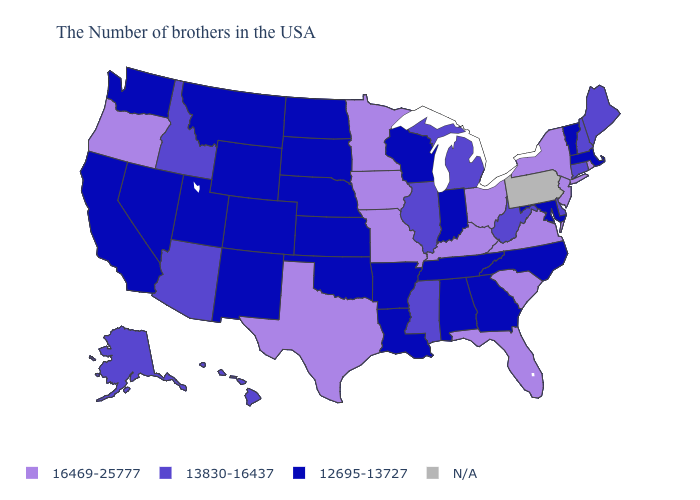What is the value of Kentucky?
Answer briefly. 16469-25777. What is the value of Oklahoma?
Concise answer only. 12695-13727. Does Oregon have the highest value in the West?
Concise answer only. Yes. Which states hav the highest value in the Northeast?
Short answer required. Rhode Island, New York, New Jersey. What is the highest value in the USA?
Answer briefly. 16469-25777. Name the states that have a value in the range 12695-13727?
Quick response, please. Massachusetts, Vermont, Maryland, North Carolina, Georgia, Indiana, Alabama, Tennessee, Wisconsin, Louisiana, Arkansas, Kansas, Nebraska, Oklahoma, South Dakota, North Dakota, Wyoming, Colorado, New Mexico, Utah, Montana, Nevada, California, Washington. Name the states that have a value in the range N/A?
Quick response, please. Pennsylvania. Name the states that have a value in the range 13830-16437?
Quick response, please. Maine, New Hampshire, Connecticut, Delaware, West Virginia, Michigan, Illinois, Mississippi, Arizona, Idaho, Alaska, Hawaii. Among the states that border Oregon , does Washington have the highest value?
Keep it brief. No. What is the highest value in states that border Massachusetts?
Short answer required. 16469-25777. Name the states that have a value in the range 12695-13727?
Keep it brief. Massachusetts, Vermont, Maryland, North Carolina, Georgia, Indiana, Alabama, Tennessee, Wisconsin, Louisiana, Arkansas, Kansas, Nebraska, Oklahoma, South Dakota, North Dakota, Wyoming, Colorado, New Mexico, Utah, Montana, Nevada, California, Washington. What is the highest value in the USA?
Give a very brief answer. 16469-25777. Does the first symbol in the legend represent the smallest category?
Answer briefly. No. Is the legend a continuous bar?
Answer briefly. No. 